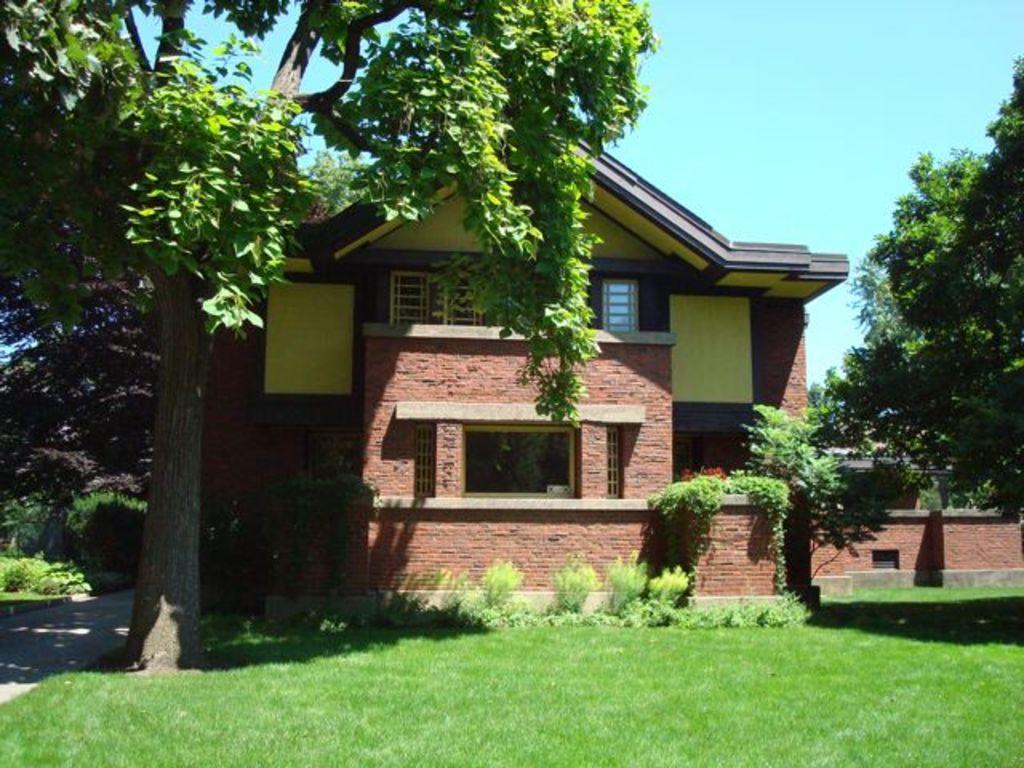In one or two sentences, can you explain what this image depicts? We can see grass,plants and house. In the background we can see trees and sky. 